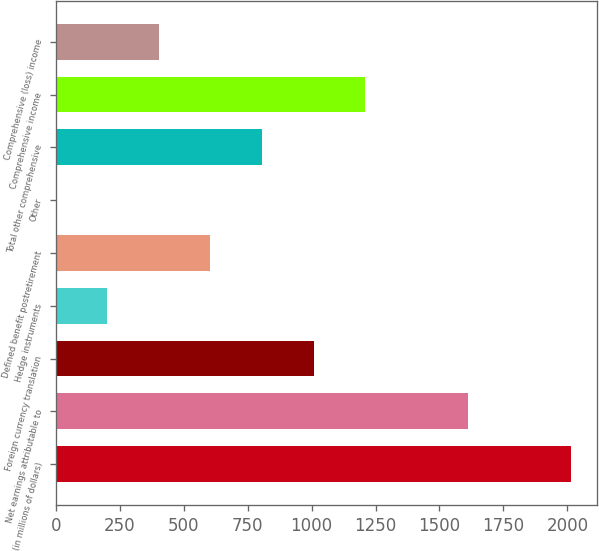Convert chart to OTSL. <chart><loc_0><loc_0><loc_500><loc_500><bar_chart><fcel>(in millions of dollars)<fcel>Net earnings attributable to<fcel>Foreign currency translation<fcel>Hedge instruments<fcel>Defined benefit postretirement<fcel>Other<fcel>Total other comprehensive<fcel>Comprehensive income<fcel>Comprehensive (loss) income<nl><fcel>2015<fcel>1612.04<fcel>1007.6<fcel>201.68<fcel>604.64<fcel>0.2<fcel>806.12<fcel>1209.08<fcel>403.16<nl></chart> 